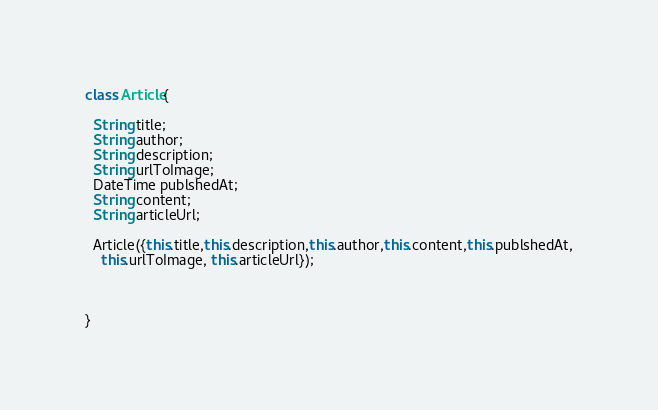Convert code to text. <code><loc_0><loc_0><loc_500><loc_500><_Dart_>class Article{

  String title;
  String author;
  String description;
  String urlToImage;
  DateTime publshedAt;
  String content;
  String articleUrl;

  Article({this.title,this.description,this.author,this.content,this.publshedAt,
    this.urlToImage, this.articleUrl});



}</code> 